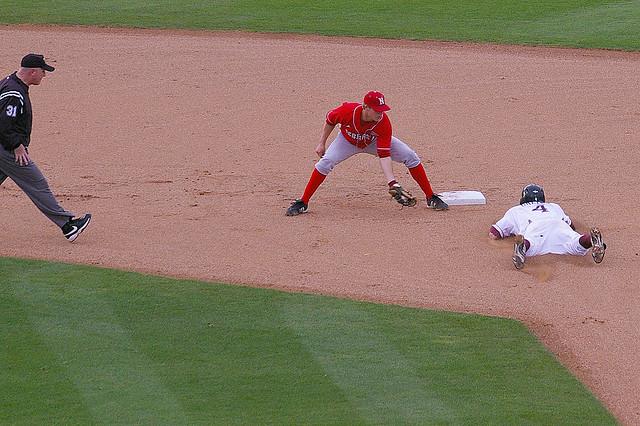What is the man in white doing with his left hand?
Concise answer only. Catching ball. Is the referee coming?
Write a very short answer. Yes. Where is the ball?
Concise answer only. Glove. Who has the ball?
Give a very brief answer. Baseman. Which player is wearing the most protective gear?
Write a very short answer. Batter. Which foot is touching the base?
Keep it brief. Left. What is the player looking at?
Give a very brief answer. Base. Did one of the players fall?
Be succinct. No. 